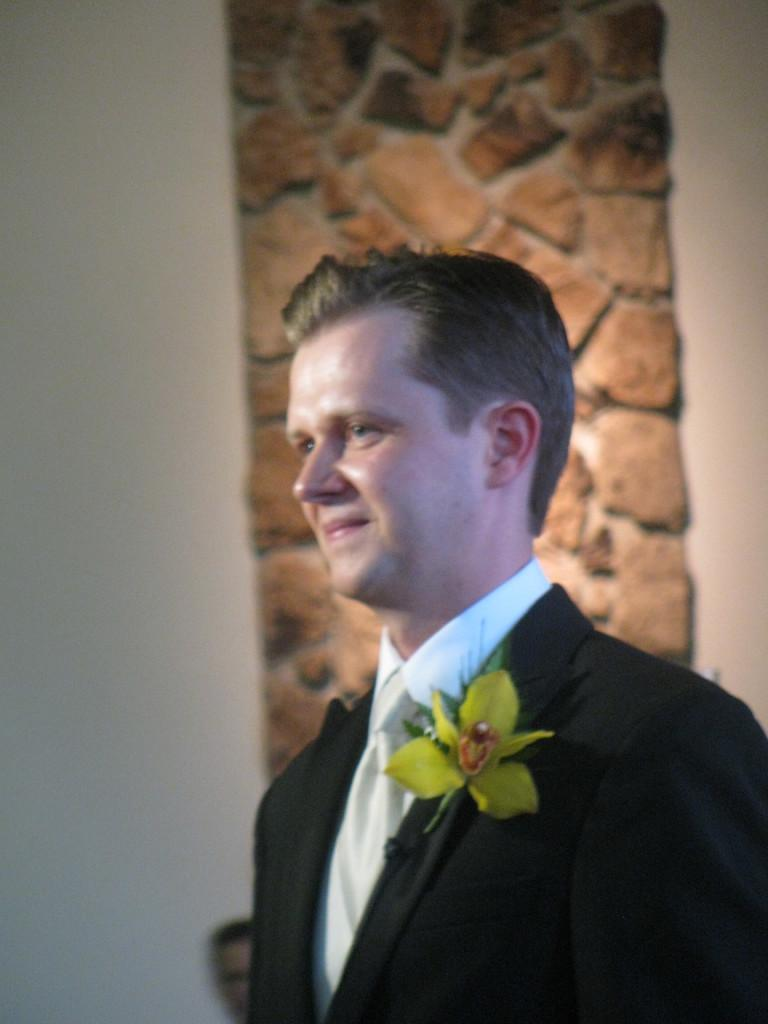What is the person in the image wearing? The person is standing with a suit in the image. Can you describe any additional details about the person's attire? The person has a flower attached to their black coat. What is the man in the image doing? The man is sitting in the image. Where is the man located in relation to the white wall? The man is near a white wall. What is the appearance of the white wall? The white wall is decorated with stones. What type of bag does the person in the image have an impulse to buy? There is no bag mentioned or visible in the image. 